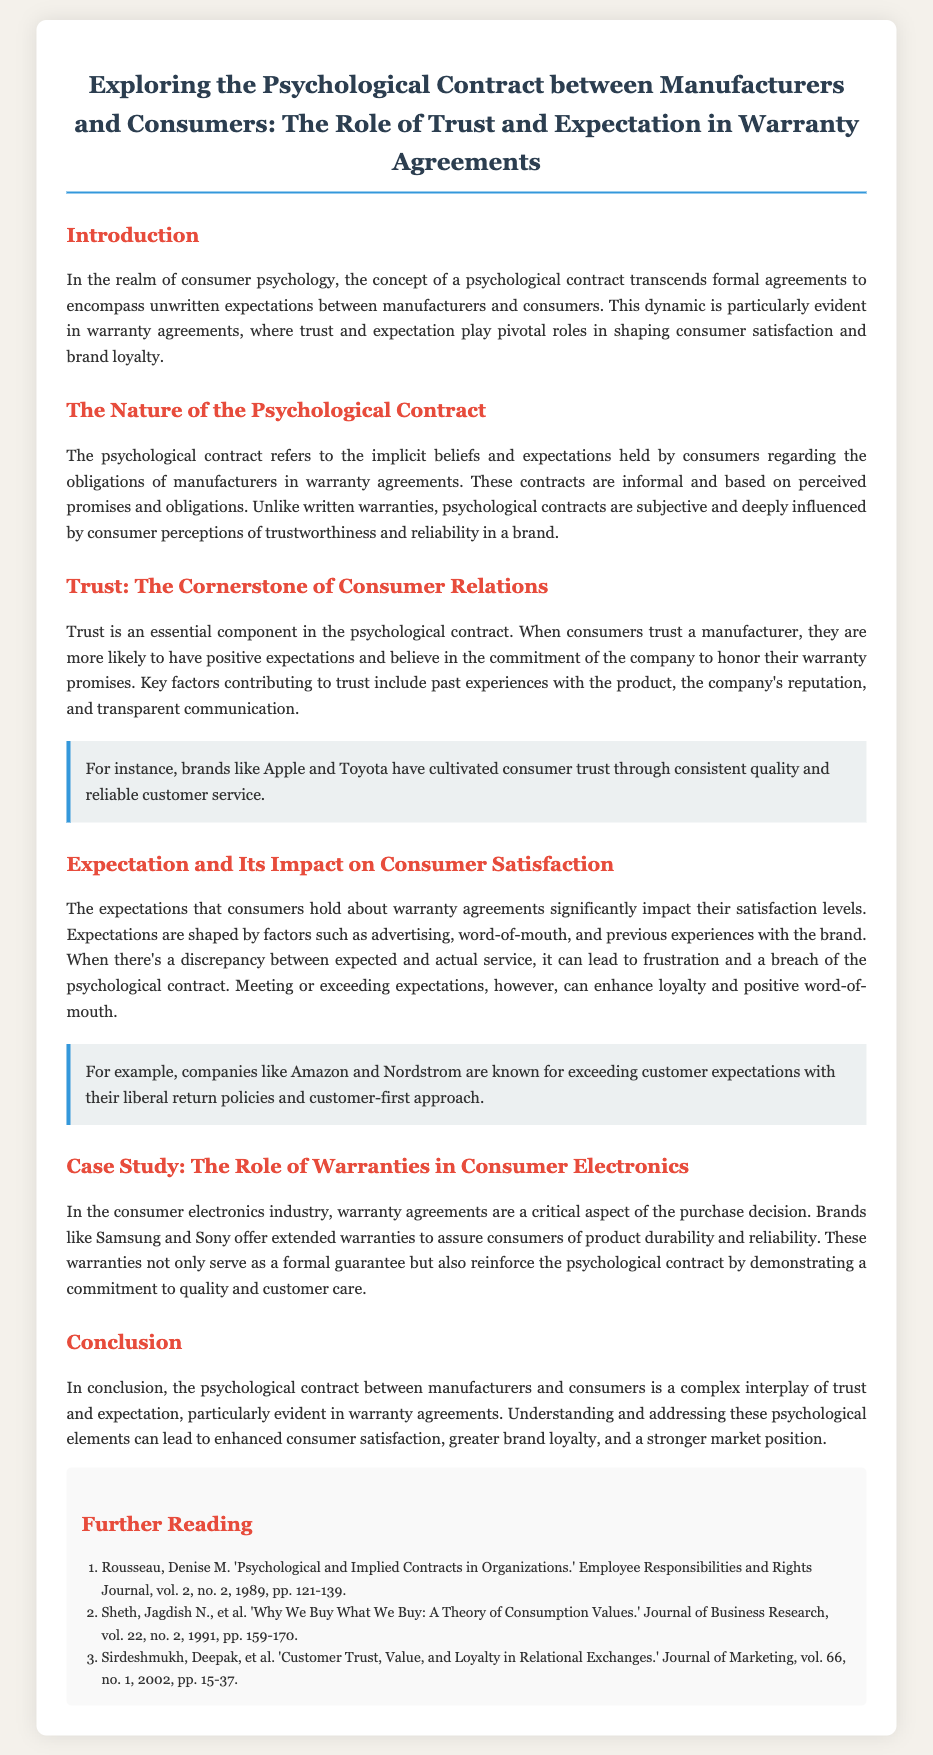What is the title of the document? The title of the document is presented at the top of the rendered content, providing insight into its focus.
Answer: Exploring the Psychological Contract between Manufacturers and Consumers: The Role of Trust and Expectation in Warranty Agreements What is the essential component in the psychological contract? The document specifies that trust is a crucial element influencing consumer relations and warranty agreements.
Answer: Trust Which brands are mentioned as examples of cultivating consumer trust? The document highlights specific brands known for their reliability and quality in the context of building trust with consumers.
Answer: Apple and Toyota What significantly impacts consumer satisfaction according to the document? The document emphasizes that consumer expectations shape their satisfaction levels regarding warranty agreements.
Answer: Expectations Which industries are discussed in the case study? The document provides a case study focused on a particular industry linked to warranty agreements and consumer trust.
Answer: Consumer electronics What kind of policies do companies like Amazon and Nordstrom have regarding customer service? The document mentions specific practices by companies that enhance consumer loyalty by meeting expectations.
Answer: Liberal return policies In what year was the reference article by Rousseau published? The reference section includes publication years for cited works, which help frame the context of the discussion in the document.
Answer: 1989 What are the two key elements discussed in the conclusion? The conclusion reiterates the main psychological aspects that influence consumer-manufacturer relationships and warranty agreements.
Answer: Trust and expectation 